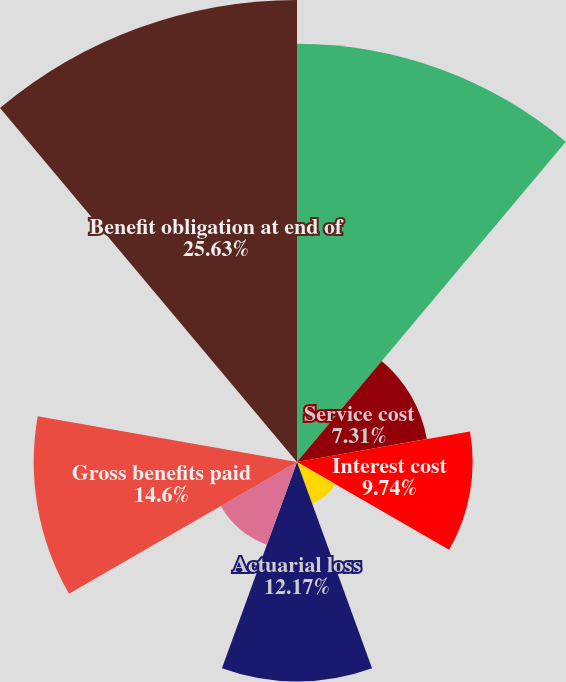Convert chart to OTSL. <chart><loc_0><loc_0><loc_500><loc_500><pie_chart><fcel>Benefit obligation at<fcel>Service cost<fcel>Interest cost<fcel>Plan participants'<fcel>Actuarial loss<fcel>Foreign currency exchange rate<fcel>Gross benefits paid<fcel>Plan amendments<fcel>Benefit obligation at end of<nl><fcel>23.19%<fcel>7.31%<fcel>9.74%<fcel>2.45%<fcel>12.17%<fcel>4.88%<fcel>14.6%<fcel>0.02%<fcel>25.62%<nl></chart> 